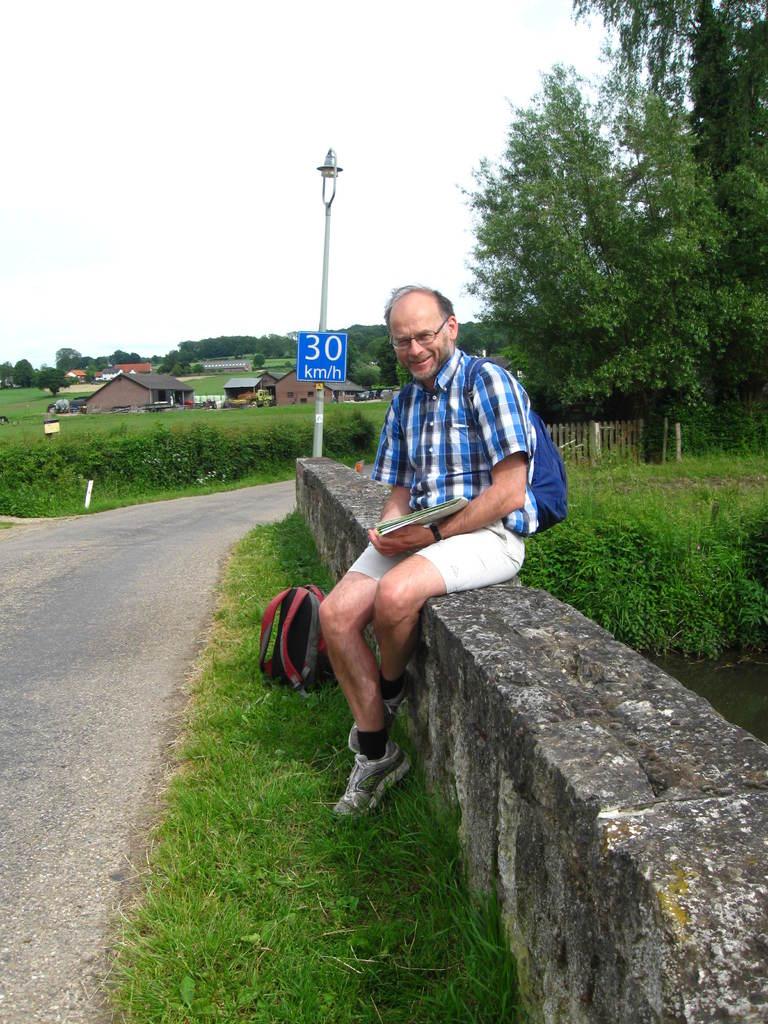Is the speed 30 miles per hour or 30 kilometers per hour?
Keep it short and to the point. Kilometers. 